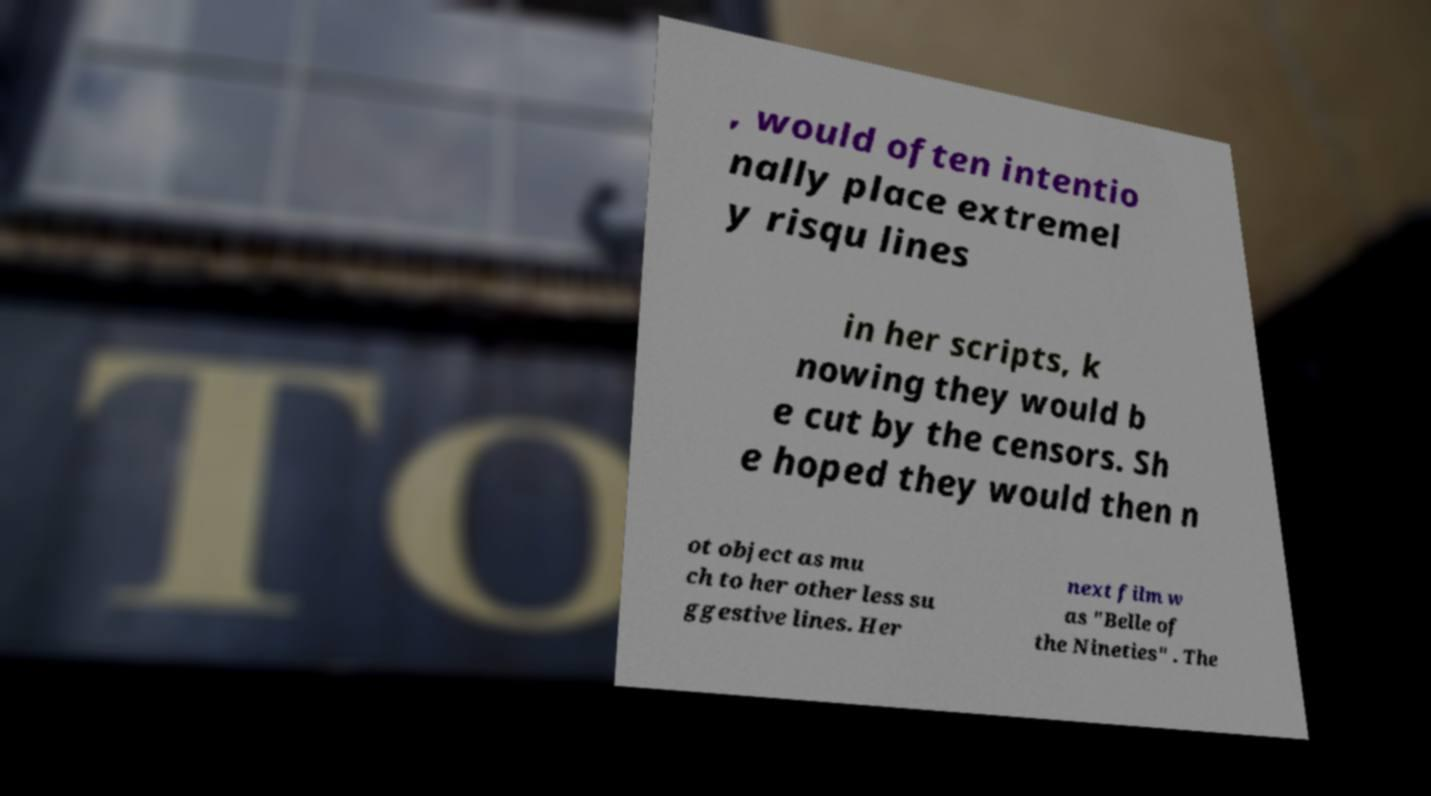Please read and relay the text visible in this image. What does it say? , would often intentio nally place extremel y risqu lines in her scripts, k nowing they would b e cut by the censors. Sh e hoped they would then n ot object as mu ch to her other less su ggestive lines. Her next film w as "Belle of the Nineties" . The 